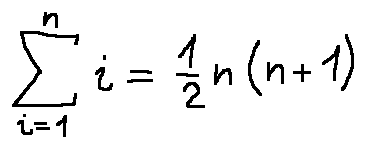Convert formula to latex. <formula><loc_0><loc_0><loc_500><loc_500>\sum \lim i t s _ { i = 1 } ^ { n } i = \frac { 1 } { 2 } n ( n + 1 )</formula> 